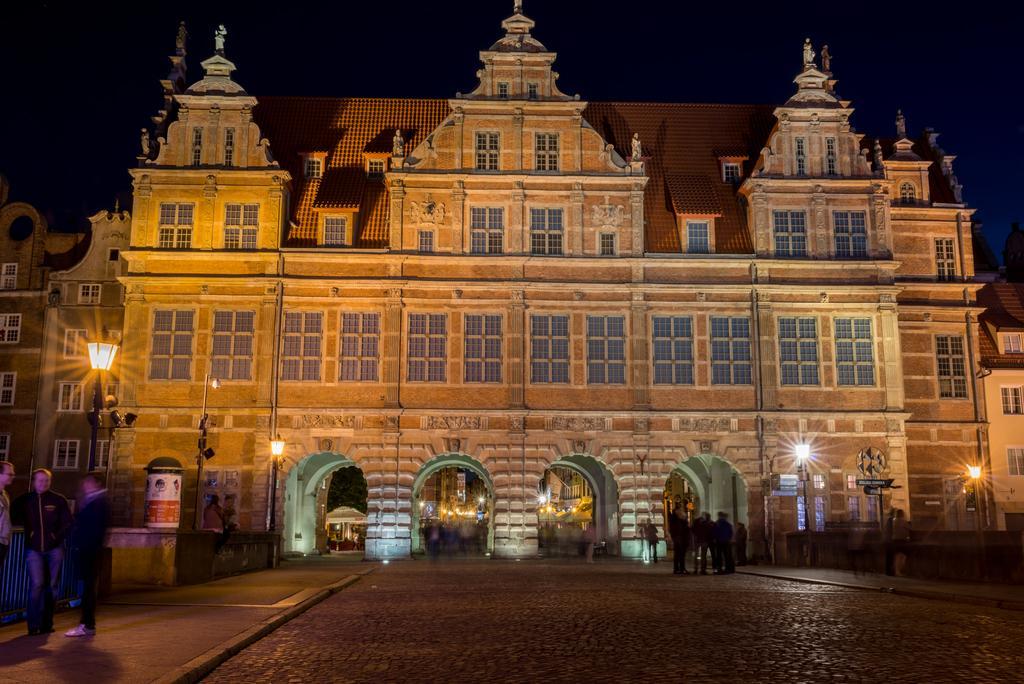Can you describe this image briefly? This image consists of a building. At the bottom, there is road. The building is in brown color. To the left, there are lights. On the pavement there are three men standing. At the top, there is sky. 